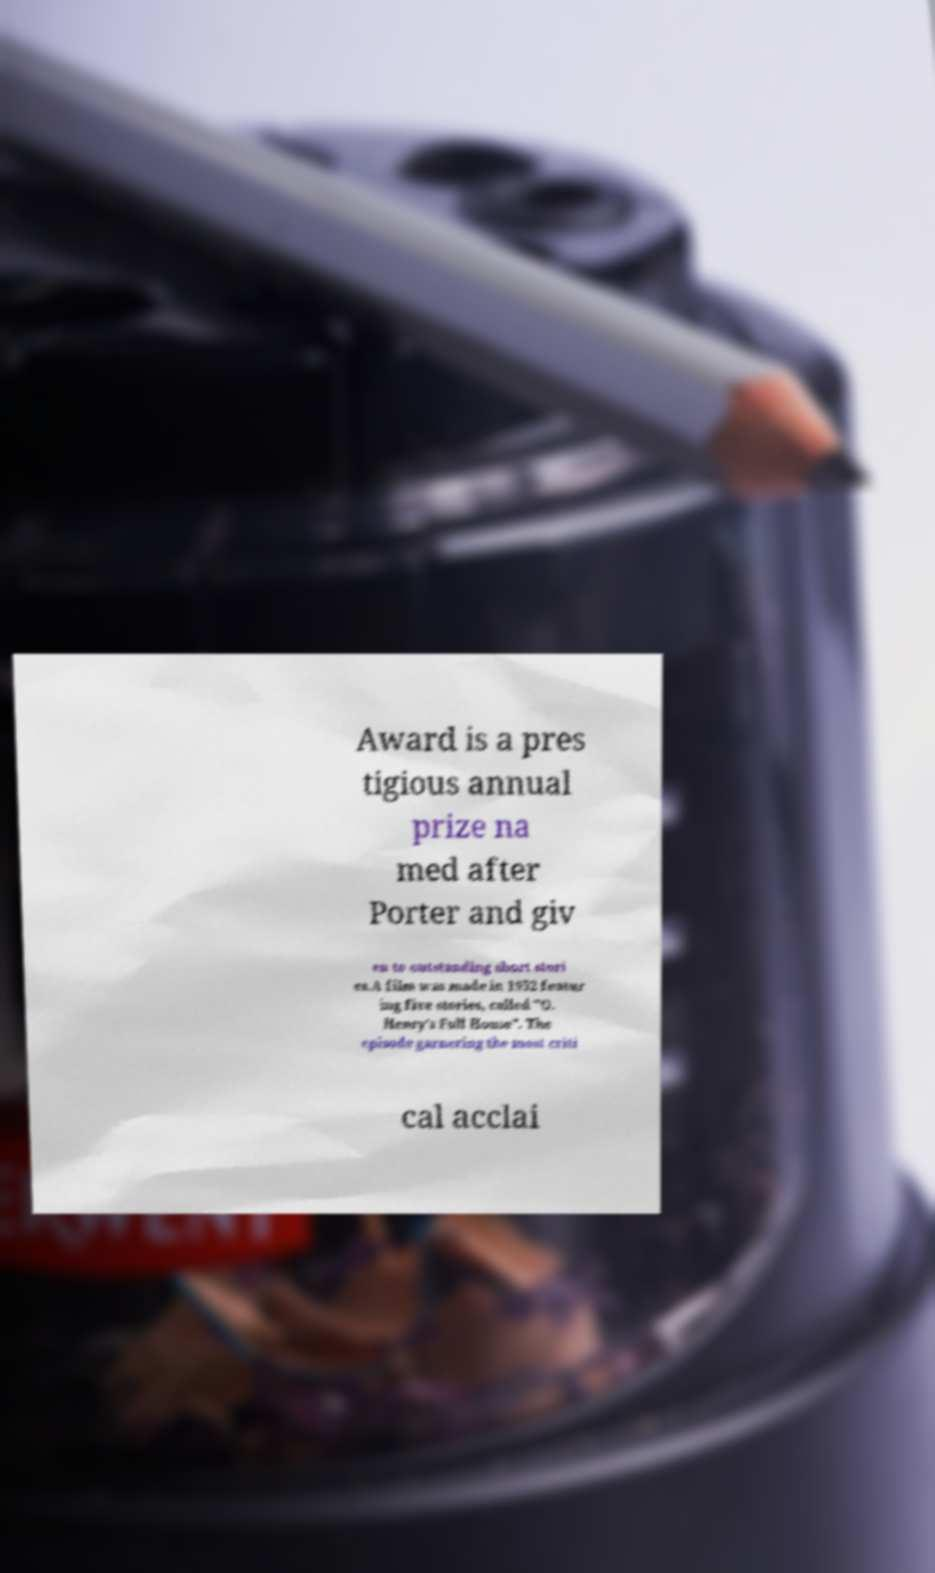Please identify and transcribe the text found in this image. Award is a pres tigious annual prize na med after Porter and giv en to outstanding short stori es.A film was made in 1952 featur ing five stories, called "O. Henry's Full House". The episode garnering the most criti cal acclai 